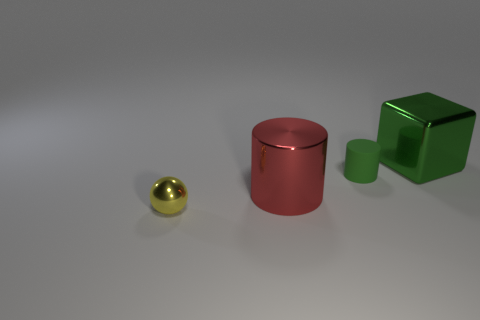Are there fewer small metallic spheres that are behind the small shiny ball than green things that are behind the small green rubber cylinder?
Offer a terse response. Yes. What number of other objects are there of the same material as the tiny green object?
Your answer should be compact. 0. There is a green thing that is the same size as the metallic cylinder; what material is it?
Make the answer very short. Metal. Are there fewer matte things that are left of the small metallic ball than big red objects?
Ensure brevity in your answer.  Yes. The small object behind the tiny yellow shiny sphere that is in front of the block that is to the right of the rubber thing is what shape?
Keep it short and to the point. Cylinder. There is a cylinder right of the large red metal cylinder; what is its size?
Your answer should be very brief. Small. There is another thing that is the same size as the green matte thing; what shape is it?
Keep it short and to the point. Sphere. What number of objects are either green metal things or metal objects to the right of the tiny yellow metal sphere?
Your response must be concise. 2. What number of small metal balls are in front of the tiny thing left of the big thing left of the large shiny block?
Keep it short and to the point. 0. What is the color of the cube that is the same material as the large cylinder?
Your response must be concise. Green. 